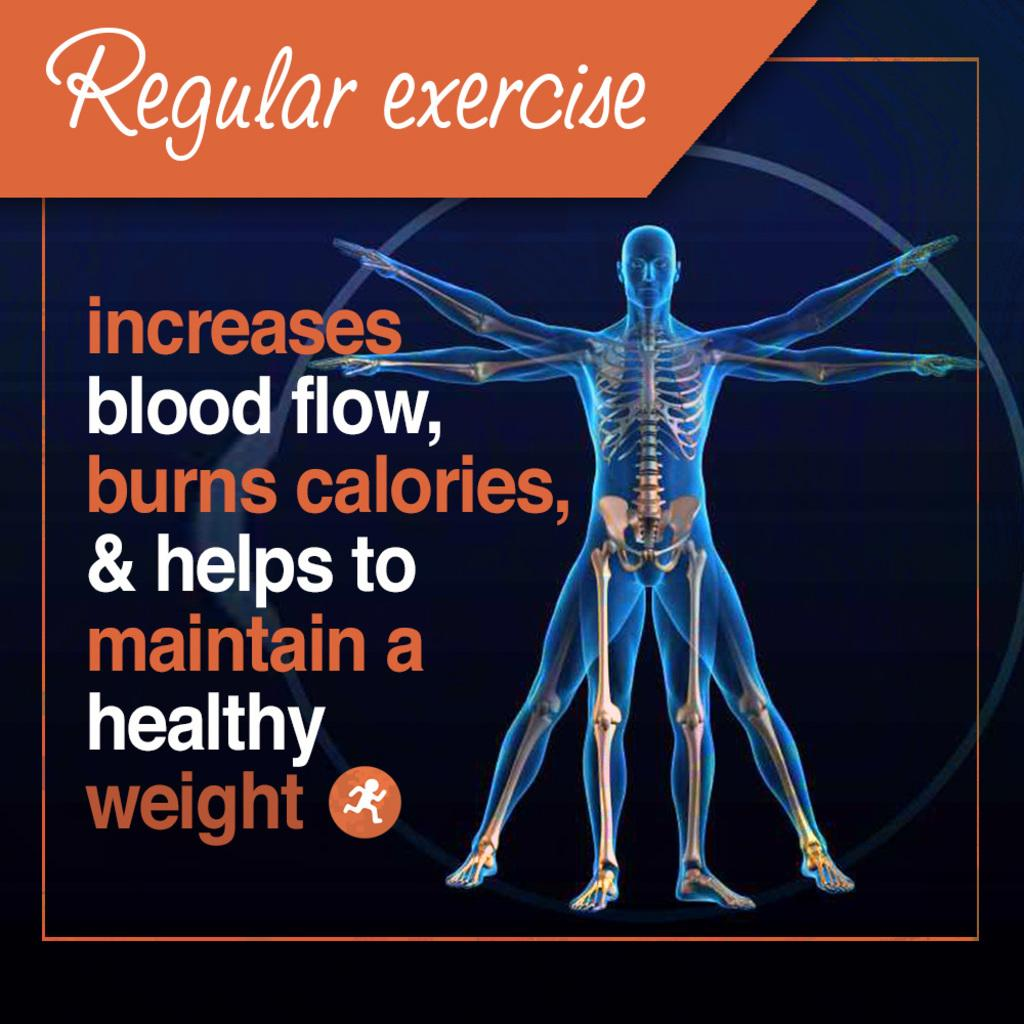Provide a one-sentence caption for the provided image. A poster promoting regular exercise notes the benefits of exercise. 